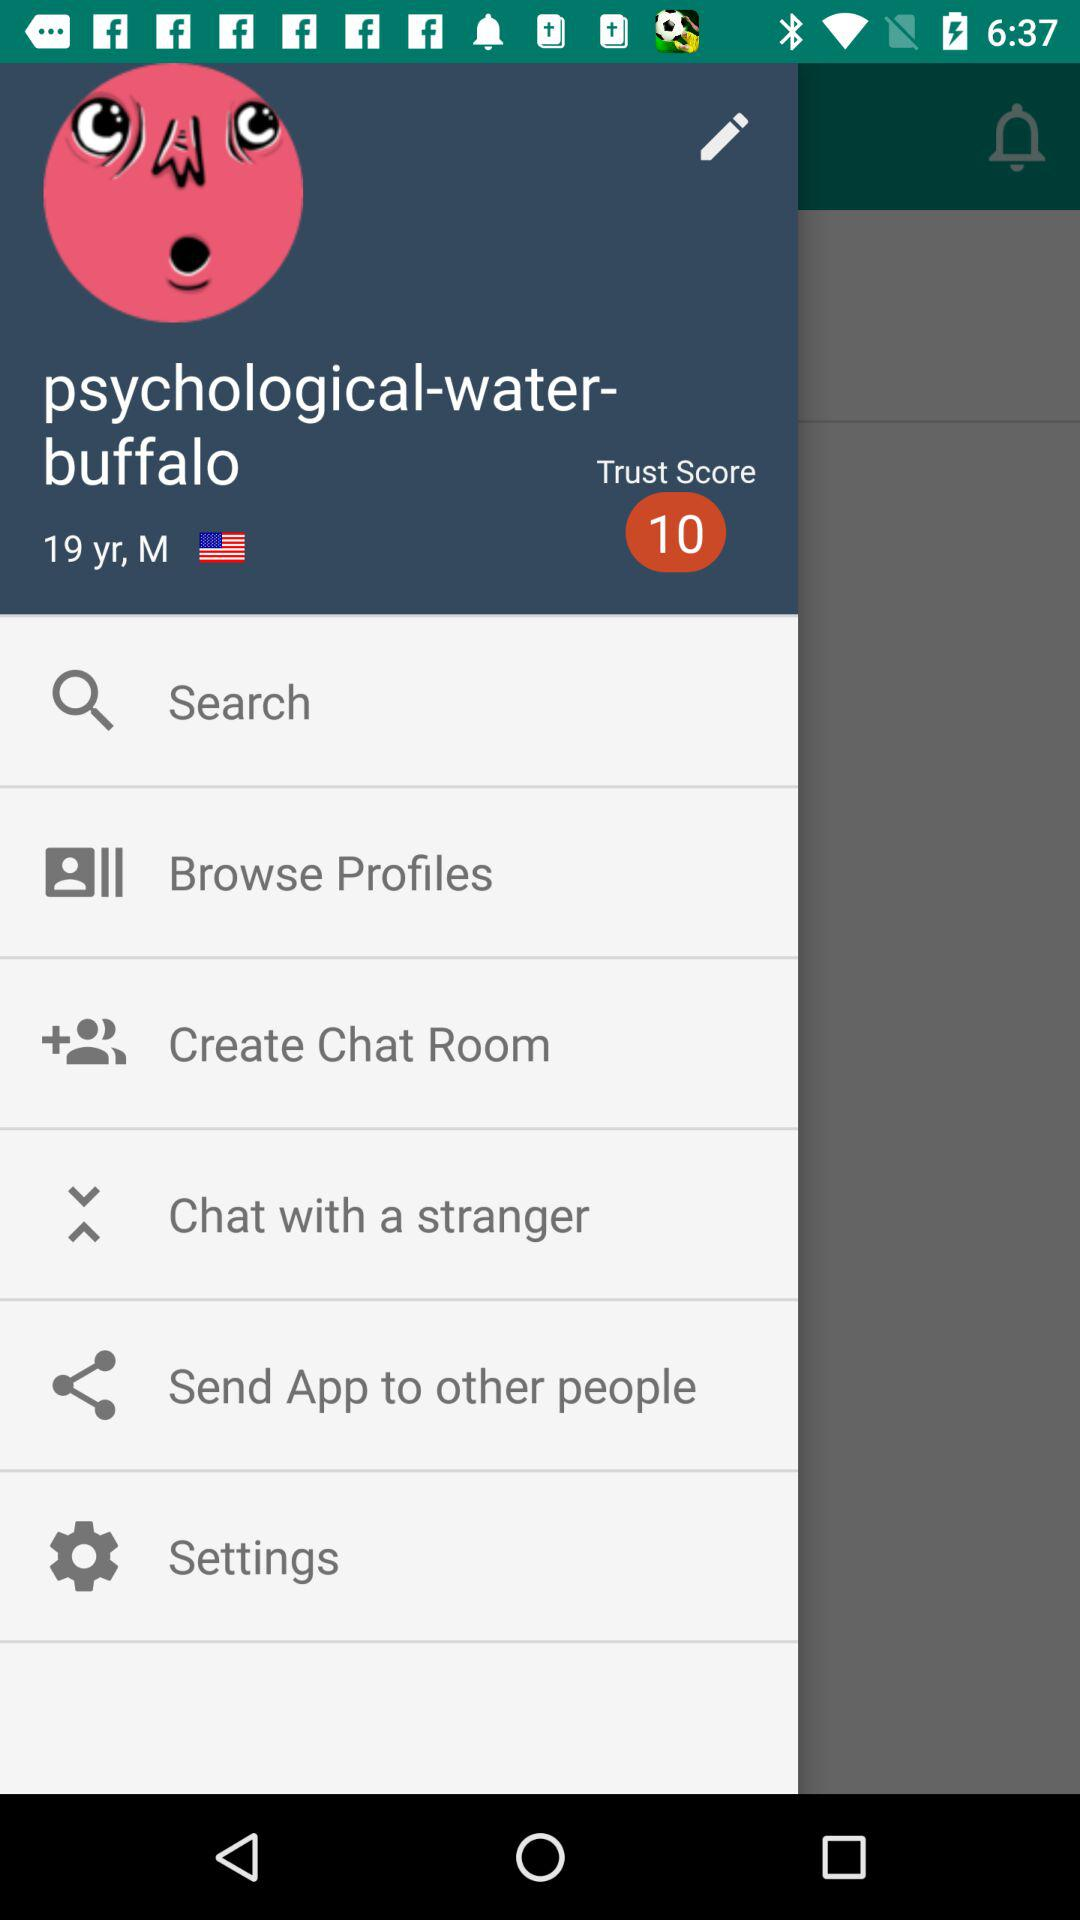What is the mentioned age? The mentioned age is "19 yr". 